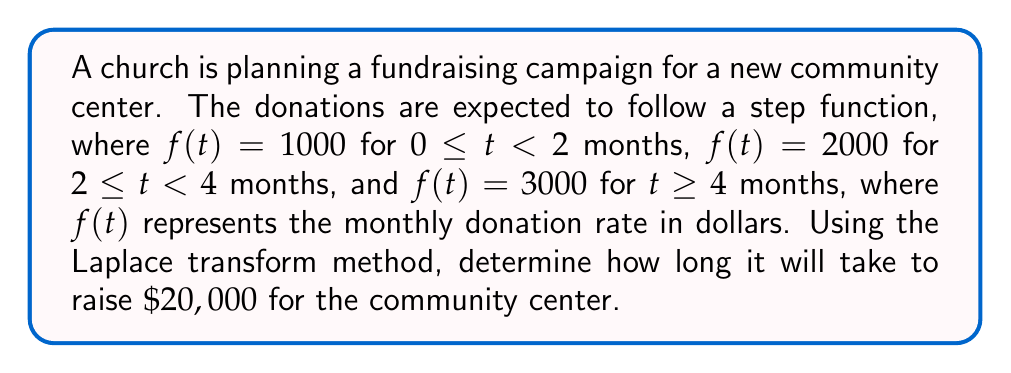What is the answer to this math problem? Let's approach this problem step-by-step using Laplace transforms:

1) First, we need to express our step function mathematically:

   $$f(t) = 1000u(t) + 1000u(t-2) + 1000u(t-4)$$

   where $u(t)$ is the unit step function.

2) The Laplace transform of this function is:

   $$F(s) = \frac{1000}{s} + \frac{1000e^{-2s}}{s} + \frac{1000e^{-4s}}{s}$$

3) To find the total amount raised, we need to integrate $f(t)$ from 0 to $T$, where $T$ is the time we're solving for. In the Laplace domain, this is equivalent to:

   $$\frac{F(s)}{s} = \frac{1000}{s^2} + \frac{1000e^{-2s}}{s^2} + \frac{1000e^{-4s}}{s^2}$$

4) To find $T$, we need to solve:

   $$\mathcal{L}^{-1}\{\frac{F(s)}{s}\} = 20000$$

5) Taking the inverse Laplace transform:

   $$1000t + 1000(t-2)u(t-2) + 1000(t-4)u(t-4) = 20000$$

6) Now, we need to solve this equation for $t$. Let's consider the intervals:

   For $0 \leq t < 2$: $1000t = 20000$ → $t = 20$ (but this is outside our interval)
   
   For $2 \leq t < 4$: $1000t + 1000(t-2) = 20000$ → $2000t - 2000 = 20000$ → $t = 11$ (also outside our interval)
   
   For $t \geq 4$: $1000t + 1000(t-2) + 1000(t-4) = 20000$ → $3000t - 6000 = 20000$ → $t = \frac{26000}{3000} = \frac{26}{3} \approx 8.67$ months

7) The solution $t = \frac{26}{3}$ months falls within the valid interval ($t \geq 4$), so this is our answer.
Answer: It will take $\frac{26}{3}$ months (approximately 8.67 months) to raise $20,000 for the community center. 